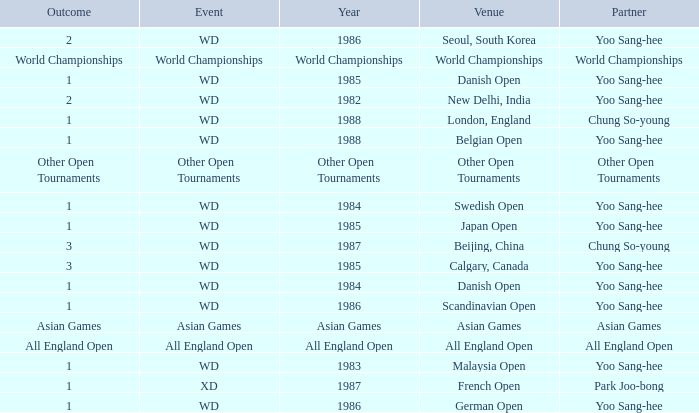What was the Outcome in 1983 of the WD Event? 1.0. 